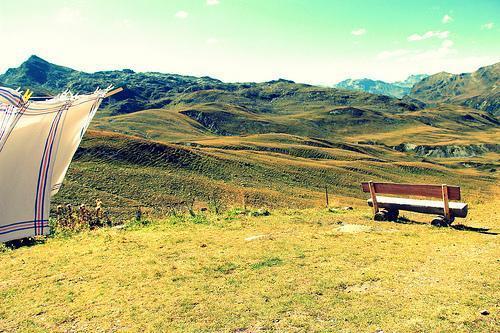How many blankets are there?
Give a very brief answer. 1. How many benches are there?
Give a very brief answer. 1. 